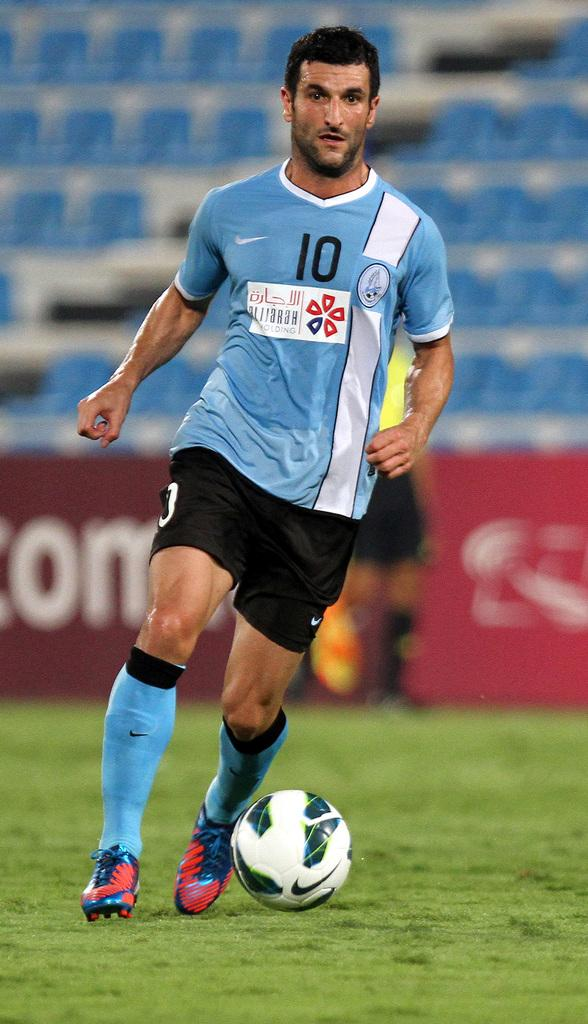Provide a one-sentence caption for the provided image. a man wearing number 10 jersey kicking the soccer ball. 